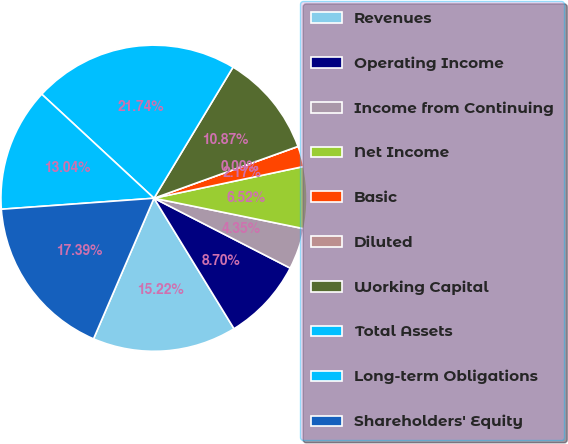<chart> <loc_0><loc_0><loc_500><loc_500><pie_chart><fcel>Revenues<fcel>Operating Income<fcel>Income from Continuing<fcel>Net Income<fcel>Basic<fcel>Diluted<fcel>Working Capital<fcel>Total Assets<fcel>Long-term Obligations<fcel>Shareholders' Equity<nl><fcel>15.22%<fcel>8.7%<fcel>4.35%<fcel>6.52%<fcel>2.17%<fcel>0.0%<fcel>10.87%<fcel>21.74%<fcel>13.04%<fcel>17.39%<nl></chart> 